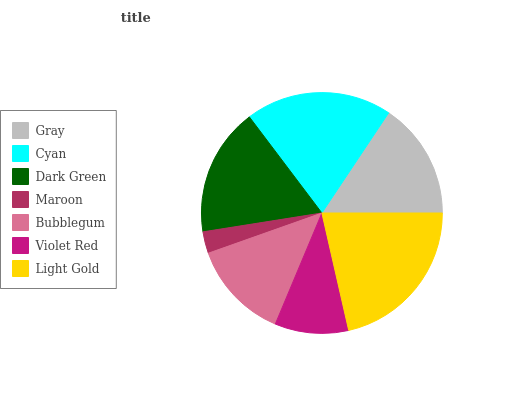Is Maroon the minimum?
Answer yes or no. Yes. Is Light Gold the maximum?
Answer yes or no. Yes. Is Cyan the minimum?
Answer yes or no. No. Is Cyan the maximum?
Answer yes or no. No. Is Cyan greater than Gray?
Answer yes or no. Yes. Is Gray less than Cyan?
Answer yes or no. Yes. Is Gray greater than Cyan?
Answer yes or no. No. Is Cyan less than Gray?
Answer yes or no. No. Is Gray the high median?
Answer yes or no. Yes. Is Gray the low median?
Answer yes or no. Yes. Is Bubblegum the high median?
Answer yes or no. No. Is Violet Red the low median?
Answer yes or no. No. 